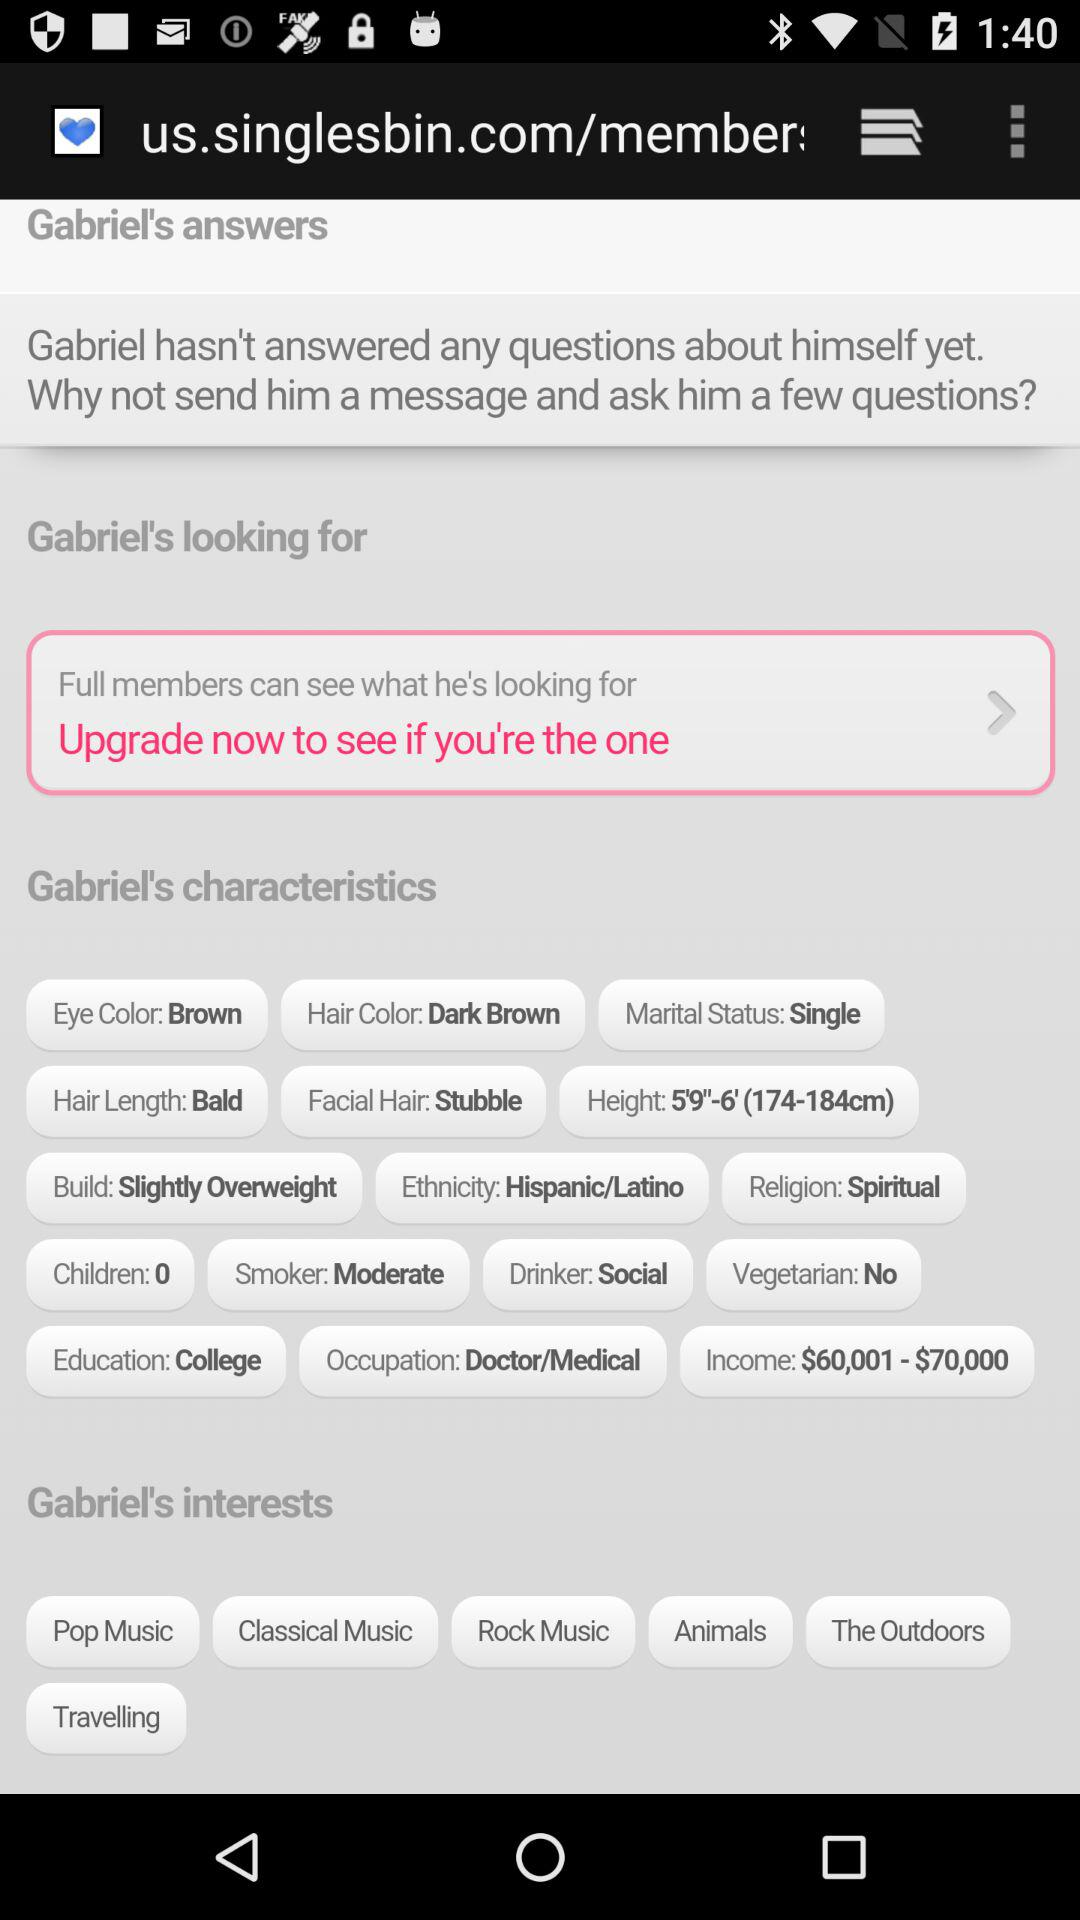What is the current step shown? The current step shown is 4. 